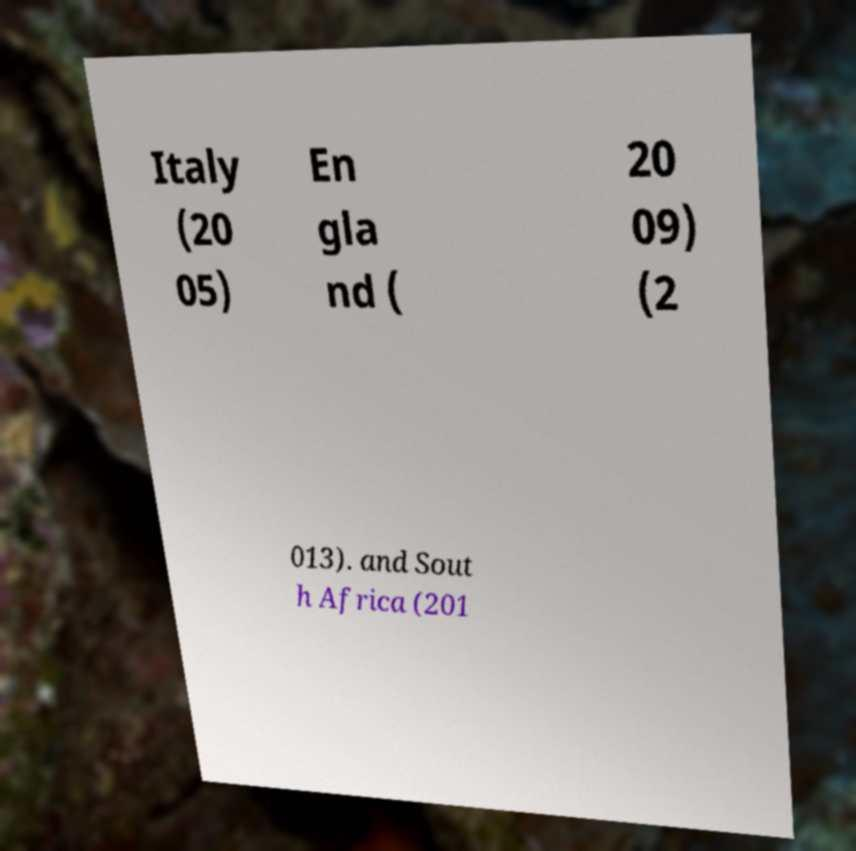Could you extract and type out the text from this image? Italy (20 05) En gla nd ( 20 09) (2 013). and Sout h Africa (201 